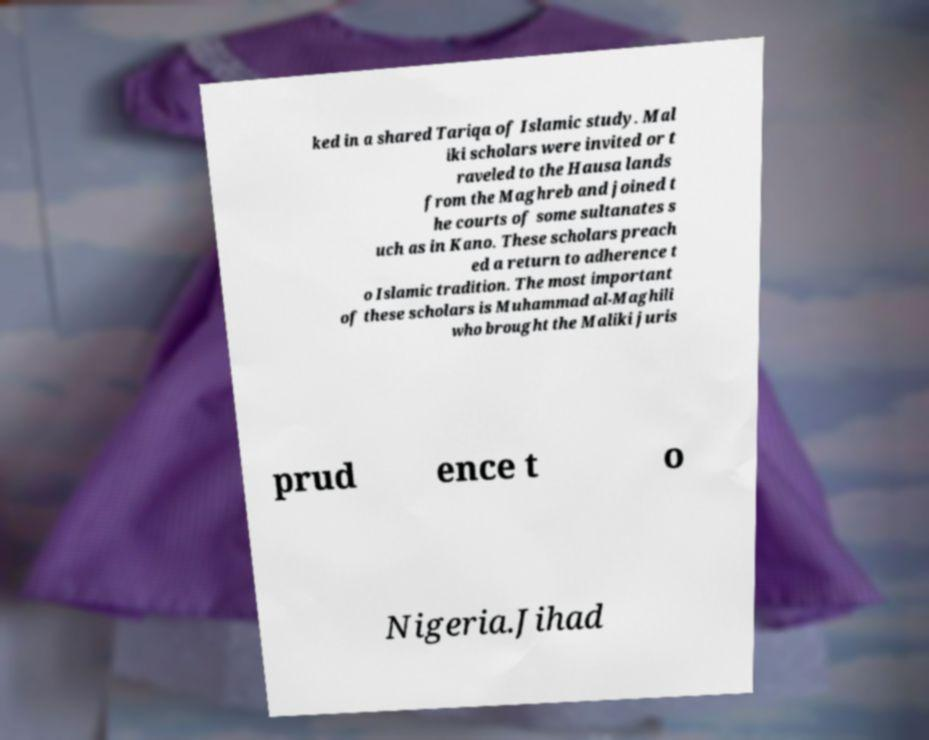What messages or text are displayed in this image? I need them in a readable, typed format. ked in a shared Tariqa of Islamic study. Mal iki scholars were invited or t raveled to the Hausa lands from the Maghreb and joined t he courts of some sultanates s uch as in Kano. These scholars preach ed a return to adherence t o Islamic tradition. The most important of these scholars is Muhammad al-Maghili who brought the Maliki juris prud ence t o Nigeria.Jihad 